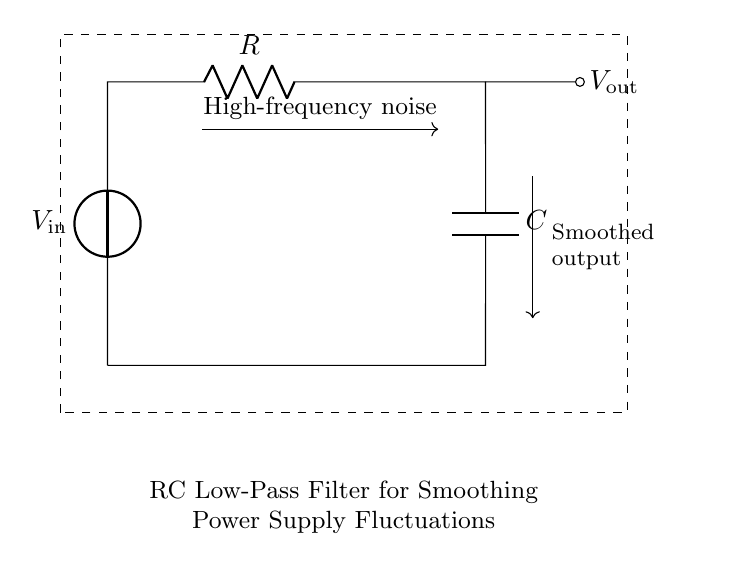What is the input voltage of the circuit? The voltage source labeled V_in indicates the input voltage to the circuit, which is based on the visual representation of the circuit diagram.
Answer: V_in What components make up this circuit? The circuit diagram visually represents an RC low-pass filter, which includes a resistor (R) and a capacitor (C), identified as part of the circuit schematic.
Answer: Resistor and Capacitor What is the role of the capacitor in this circuit? The capacitor is responsible for smoothing out fluctuations, which means it absorbs high-frequency noise and allows for a more stable output voltage, as indicated by its placement and connection in the circuit.
Answer: Smoothing What kind of filter does this circuit represent? The circuit is designed as a low-pass filter, as evidenced by the resistor-capacitor arrangement, allowing low-frequency signals to pass while attenuating high-frequency signals.
Answer: Low-pass filter What happens to high-frequency signals in this circuit? High-frequency noise is redirected and reduced in amplitude by the filter's configuration, specifically through the capacitor, resulting in a more stable output. This can be seen in the diagram with the directional arrows indicating this process.
Answer: Attenuated What is the output voltage of the circuit? The output voltage, labeled V_out in the circuit diagram, is the result of the filtering effect of the resistor and capacitor, which produces a smoothed version of the input voltage.
Answer: V_out 